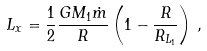Convert formula to latex. <formula><loc_0><loc_0><loc_500><loc_500>L _ { x } = \frac { 1 } { 2 } \frac { G M _ { 1 } \dot { m } } { R } \left ( 1 - \frac { R } { R _ { L _ { 1 } } } \right ) \, ,</formula> 